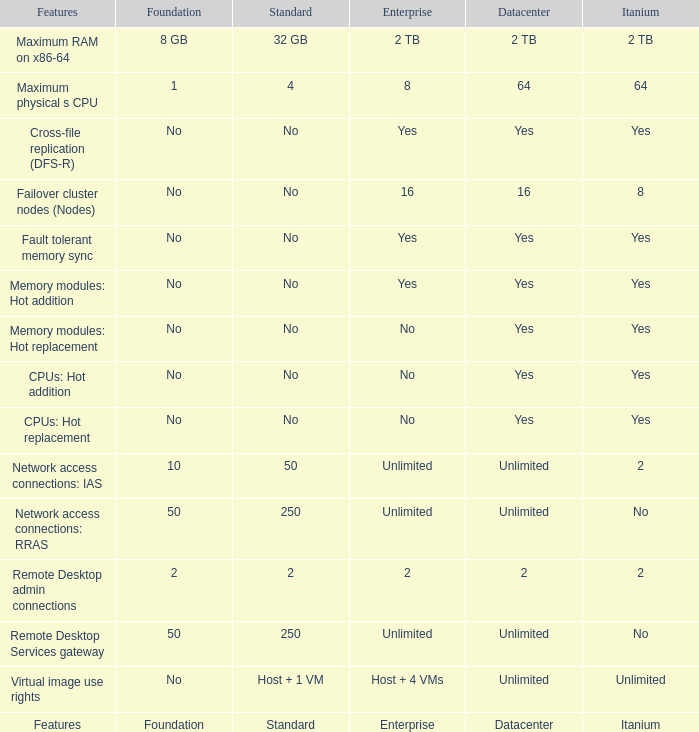Which Features have Yes listed under Datacenter? Cross-file replication (DFS-R), Fault tolerant memory sync, Memory modules: Hot addition, Memory modules: Hot replacement, CPUs: Hot addition, CPUs: Hot replacement. 